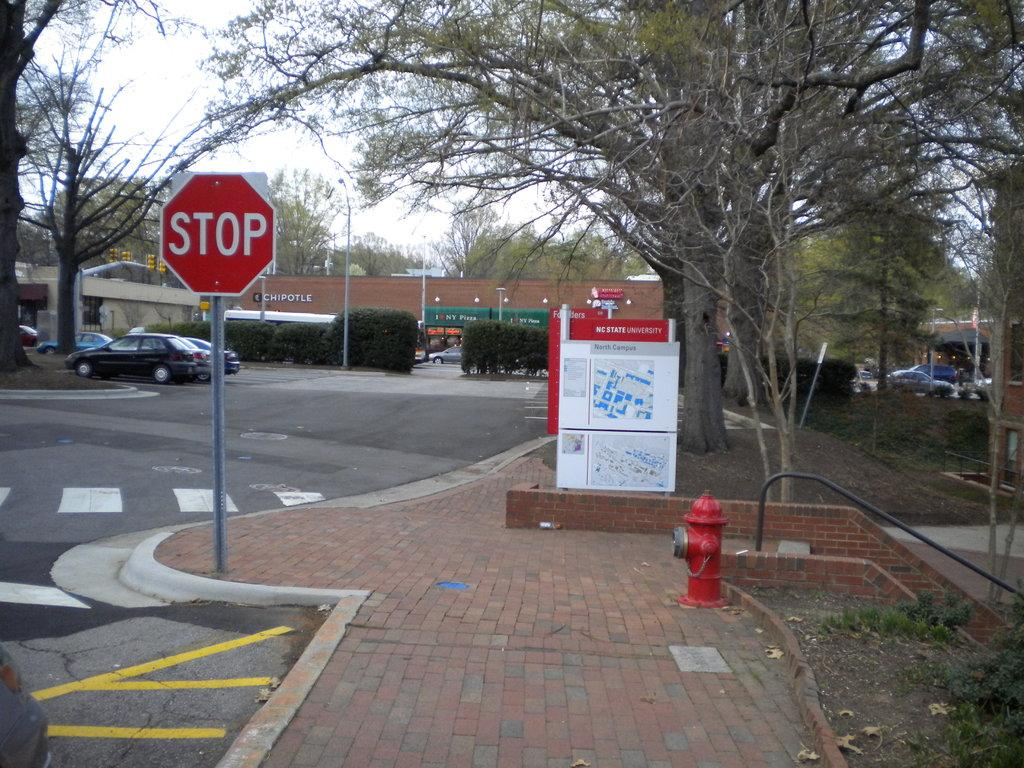<image>
Summarize the visual content of the image. A red sign says Stop and a Chipotle restaurant is in the background. 